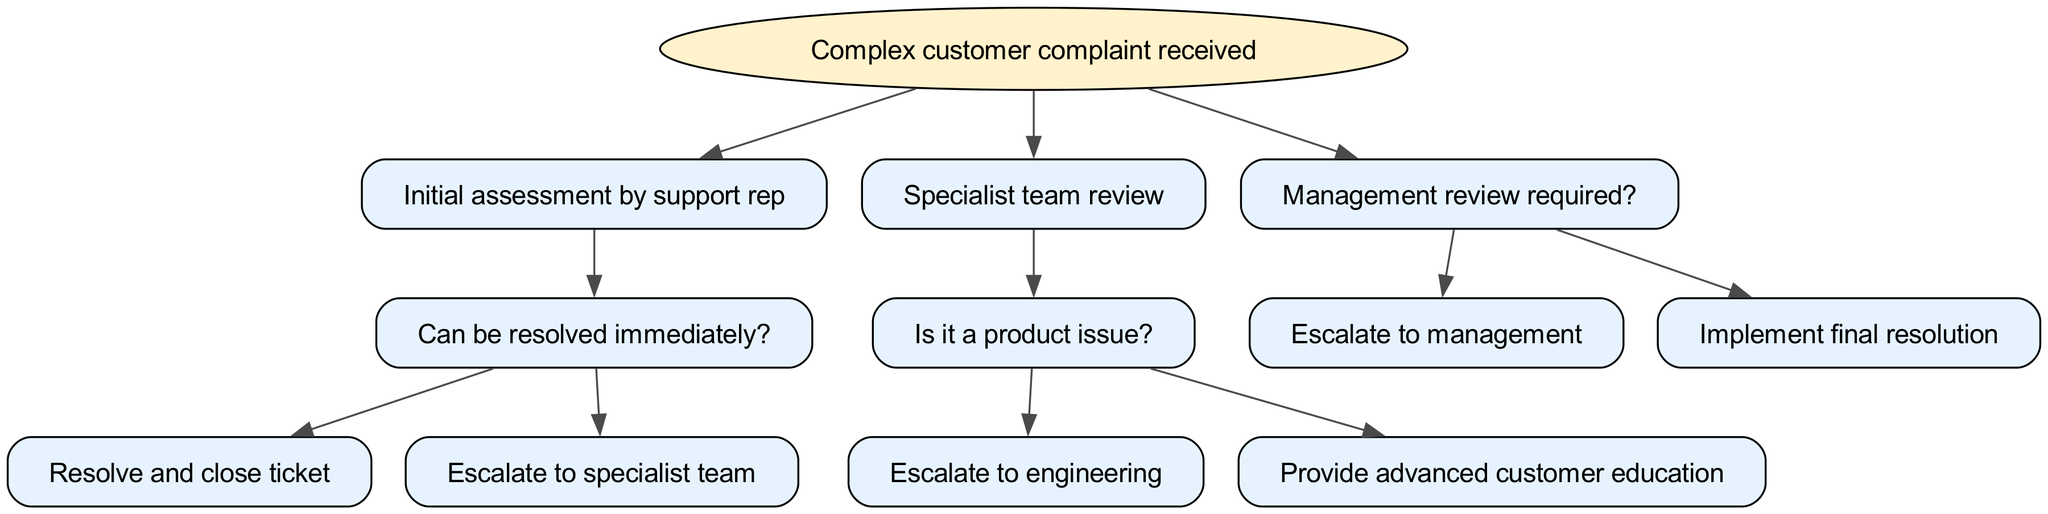What is the root node of the decision tree? The root node is the starting point of the decision-making process in the diagram, and it is labeled "Complex customer complaint received."
Answer: Complex customer complaint received How many nodes are there in the decision tree? By counting the nodes in the diagram, including the root and all subsequent nodes, there is a total of 7 nodes.
Answer: 7 What decision follows the initial assessment by the support rep? After the initial assessment, if the complaint can be resolved immediately, the next decision is to either "Resolve and close ticket" or "Escalate to specialist team."
Answer: Resolve and close ticket or Escalate to specialist team If a specialist team identifies a product issue, what is the next step? If a product issue is identified, the decision tree indicates that the next step is to "Escalate to engineering" or "Provide advanced customer education."
Answer: Escalate to engineering or Provide advanced customer education What leads to the management review in the diagram? The branch leading to "Management review required?" occurs after the specialist team review and is determined by whether further escalation is needed.
Answer: Management review required What are the possible outcomes after management review? After the management review, the possible outcomes are "Escalate to management" or "Implement final resolution."
Answer: Escalate to management or Implement final resolution Which node indicates a resolution that can be executed immediately? The node that indicates a resolution that can be executed immediately is identified as "Can be resolved immediately?" stemming from "Initial assessment by support rep."
Answer: Can be resolved immediately How many decisions lead from the initial assessment? There are two decisions that directly lead from the initial assessment node: "Resolve and close ticket" and "Escalate to specialist team."
Answer: 2 What does the decision tree ultimately aim to achieve? The ultimate aim of this decision tree is to effectively manage and resolve complex customer complaints through a series of logical steps and assessments.
Answer: Resolve complex customer complaints 